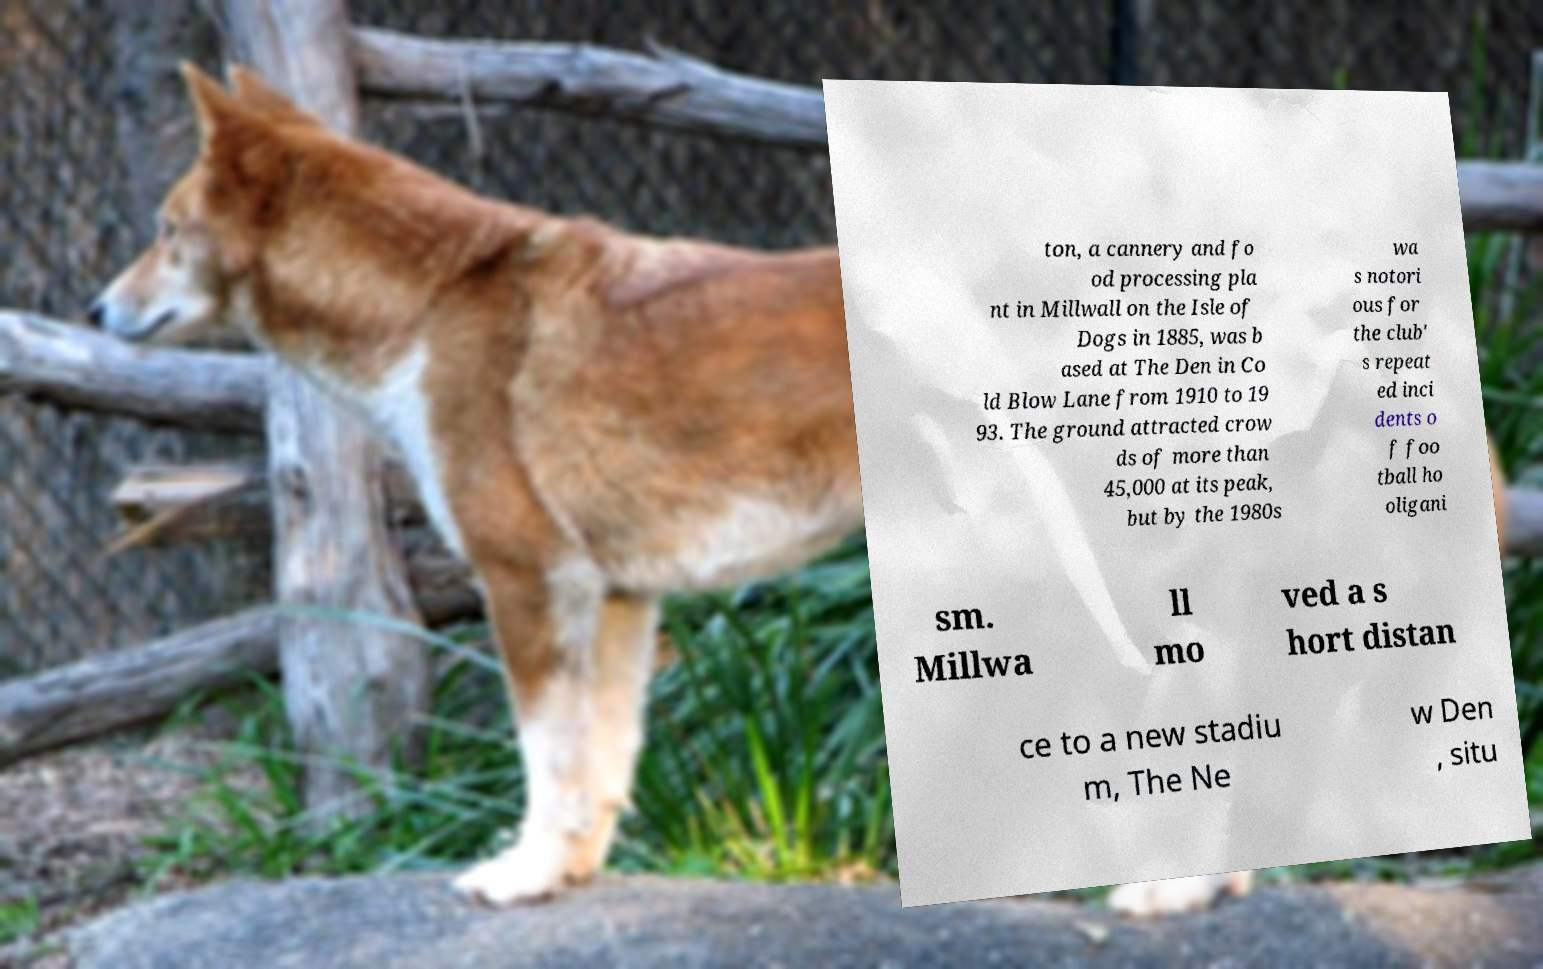There's text embedded in this image that I need extracted. Can you transcribe it verbatim? ton, a cannery and fo od processing pla nt in Millwall on the Isle of Dogs in 1885, was b ased at The Den in Co ld Blow Lane from 1910 to 19 93. The ground attracted crow ds of more than 45,000 at its peak, but by the 1980s wa s notori ous for the club' s repeat ed inci dents o f foo tball ho oligani sm. Millwa ll mo ved a s hort distan ce to a new stadiu m, The Ne w Den , situ 